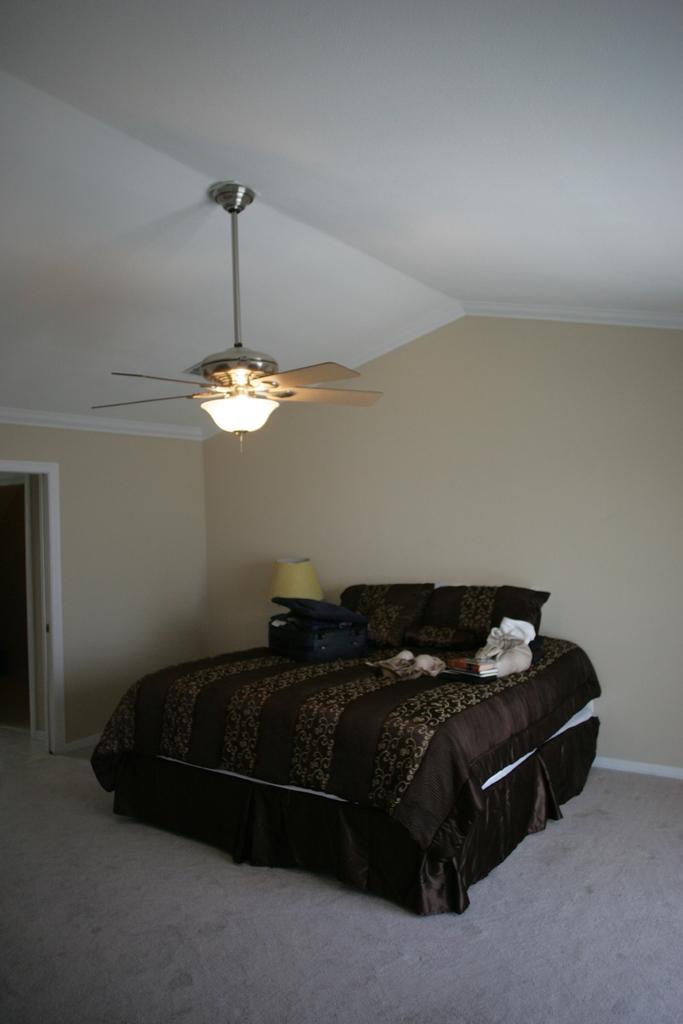Could you give a brief overview of what you see in this image? In this image I can see a bed on which I can see a bed sheet which is brown in color and I can see a suitcase and few other objects on the bed. I can see the cream colored wall, the white colored ceiling and a fan and I can see a lamp beside the bed. 